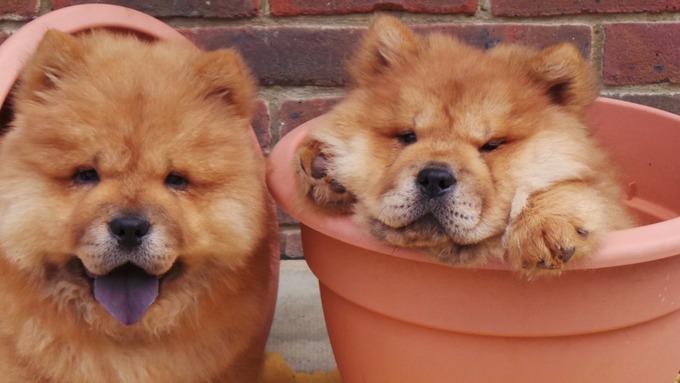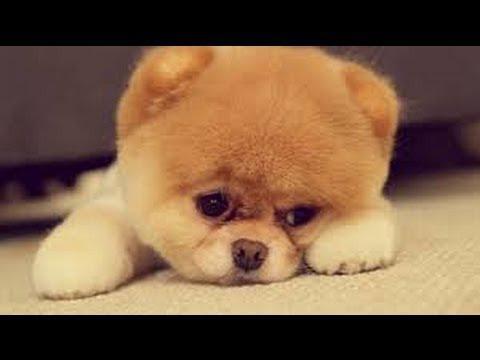The first image is the image on the left, the second image is the image on the right. For the images displayed, is the sentence "The combined images include two chows and one other animal figure, all are the same color, and at least two have their paws forward." factually correct? Answer yes or no. Yes. The first image is the image on the left, the second image is the image on the right. Examine the images to the left and right. Is the description "The left and right image contains the same number of dogs with at least one laying down." accurate? Answer yes or no. No. 